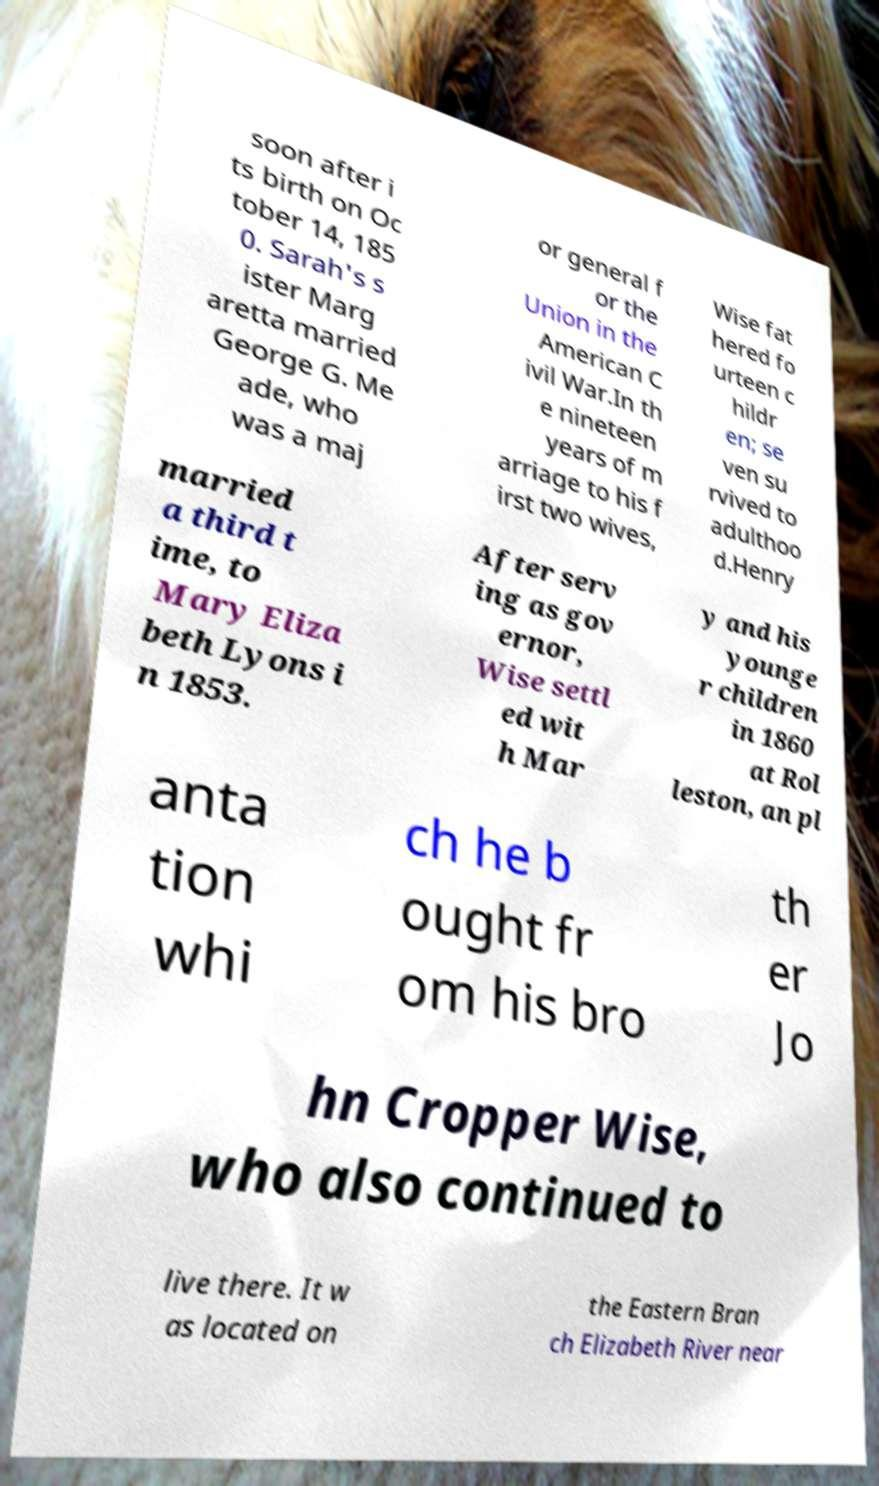Can you accurately transcribe the text from the provided image for me? soon after i ts birth on Oc tober 14, 185 0. Sarah's s ister Marg aretta married George G. Me ade, who was a maj or general f or the Union in the American C ivil War.In th e nineteen years of m arriage to his f irst two wives, Wise fat hered fo urteen c hildr en; se ven su rvived to adulthoo d.Henry married a third t ime, to Mary Eliza beth Lyons i n 1853. After serv ing as gov ernor, Wise settl ed wit h Mar y and his younge r children in 1860 at Rol leston, an pl anta tion whi ch he b ought fr om his bro th er Jo hn Cropper Wise, who also continued to live there. It w as located on the Eastern Bran ch Elizabeth River near 